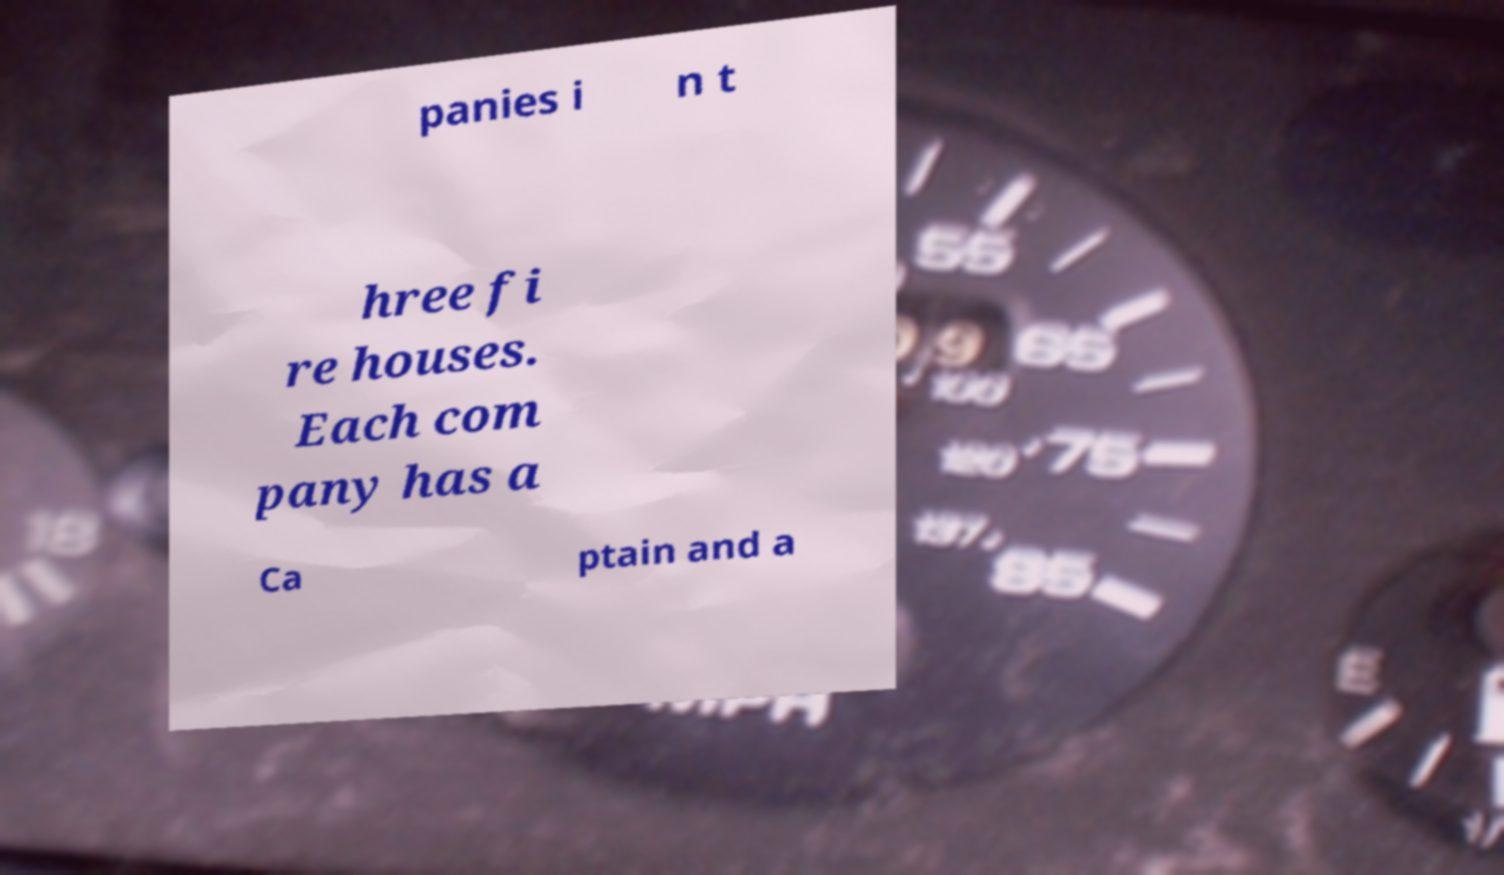What messages or text are displayed in this image? I need them in a readable, typed format. panies i n t hree fi re houses. Each com pany has a Ca ptain and a 